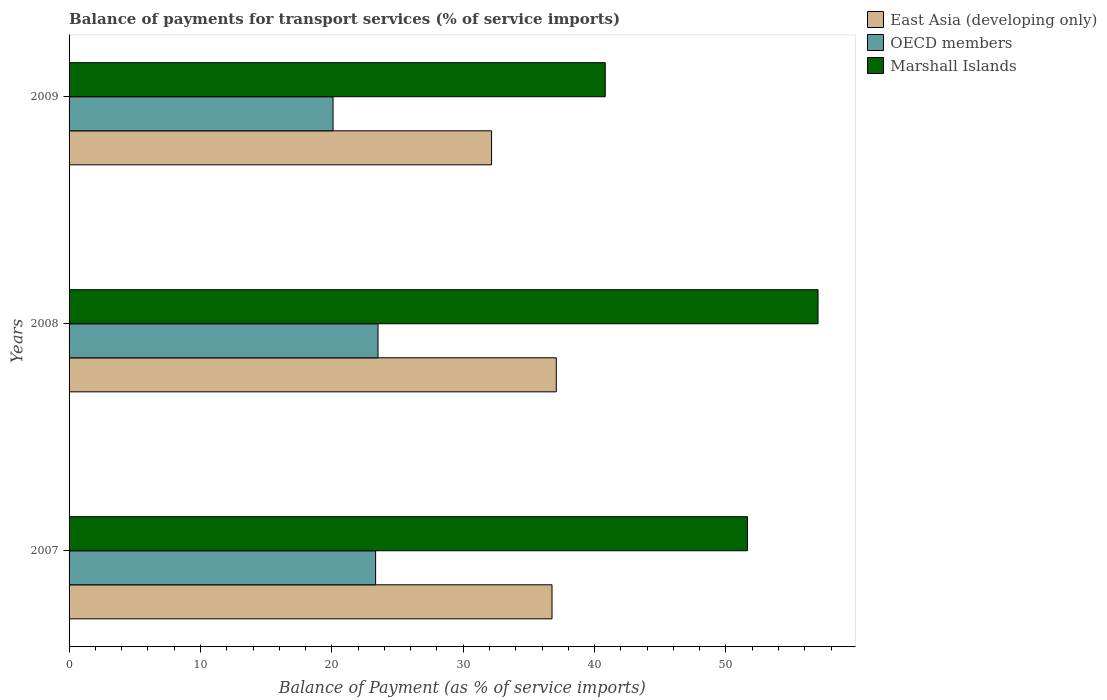How many groups of bars are there?
Offer a terse response. 3. Are the number of bars per tick equal to the number of legend labels?
Give a very brief answer. Yes. How many bars are there on the 3rd tick from the top?
Provide a succinct answer. 3. In how many cases, is the number of bars for a given year not equal to the number of legend labels?
Keep it short and to the point. 0. What is the balance of payments for transport services in Marshall Islands in 2008?
Ensure brevity in your answer.  57.01. Across all years, what is the maximum balance of payments for transport services in Marshall Islands?
Provide a short and direct response. 57.01. Across all years, what is the minimum balance of payments for transport services in Marshall Islands?
Provide a short and direct response. 40.81. What is the total balance of payments for transport services in OECD members in the graph?
Give a very brief answer. 66.94. What is the difference between the balance of payments for transport services in Marshall Islands in 2007 and that in 2009?
Offer a very short reply. 10.83. What is the difference between the balance of payments for transport services in East Asia (developing only) in 2009 and the balance of payments for transport services in OECD members in 2007?
Offer a very short reply. 8.83. What is the average balance of payments for transport services in East Asia (developing only) per year?
Your answer should be compact. 35.34. In the year 2008, what is the difference between the balance of payments for transport services in OECD members and balance of payments for transport services in Marshall Islands?
Your answer should be very brief. -33.49. What is the ratio of the balance of payments for transport services in Marshall Islands in 2007 to that in 2008?
Your answer should be very brief. 0.91. What is the difference between the highest and the second highest balance of payments for transport services in OECD members?
Ensure brevity in your answer.  0.18. What is the difference between the highest and the lowest balance of payments for transport services in Marshall Islands?
Your response must be concise. 16.2. What does the 1st bar from the top in 2008 represents?
Your answer should be compact. Marshall Islands. What does the 3rd bar from the bottom in 2009 represents?
Your answer should be very brief. Marshall Islands. Is it the case that in every year, the sum of the balance of payments for transport services in OECD members and balance of payments for transport services in Marshall Islands is greater than the balance of payments for transport services in East Asia (developing only)?
Offer a very short reply. Yes. What is the difference between two consecutive major ticks on the X-axis?
Provide a succinct answer. 10. Does the graph contain any zero values?
Your answer should be very brief. No. Does the graph contain grids?
Offer a terse response. No. How are the legend labels stacked?
Your answer should be compact. Vertical. What is the title of the graph?
Provide a succinct answer. Balance of payments for transport services (% of service imports). What is the label or title of the X-axis?
Provide a succinct answer. Balance of Payment (as % of service imports). What is the label or title of the Y-axis?
Offer a very short reply. Years. What is the Balance of Payment (as % of service imports) of East Asia (developing only) in 2007?
Ensure brevity in your answer.  36.76. What is the Balance of Payment (as % of service imports) in OECD members in 2007?
Ensure brevity in your answer.  23.33. What is the Balance of Payment (as % of service imports) of Marshall Islands in 2007?
Make the answer very short. 51.64. What is the Balance of Payment (as % of service imports) in East Asia (developing only) in 2008?
Make the answer very short. 37.09. What is the Balance of Payment (as % of service imports) of OECD members in 2008?
Your answer should be very brief. 23.52. What is the Balance of Payment (as % of service imports) in Marshall Islands in 2008?
Your answer should be very brief. 57.01. What is the Balance of Payment (as % of service imports) of East Asia (developing only) in 2009?
Your answer should be very brief. 32.16. What is the Balance of Payment (as % of service imports) of OECD members in 2009?
Provide a succinct answer. 20.09. What is the Balance of Payment (as % of service imports) in Marshall Islands in 2009?
Your response must be concise. 40.81. Across all years, what is the maximum Balance of Payment (as % of service imports) in East Asia (developing only)?
Ensure brevity in your answer.  37.09. Across all years, what is the maximum Balance of Payment (as % of service imports) of OECD members?
Provide a succinct answer. 23.52. Across all years, what is the maximum Balance of Payment (as % of service imports) in Marshall Islands?
Give a very brief answer. 57.01. Across all years, what is the minimum Balance of Payment (as % of service imports) of East Asia (developing only)?
Give a very brief answer. 32.16. Across all years, what is the minimum Balance of Payment (as % of service imports) of OECD members?
Ensure brevity in your answer.  20.09. Across all years, what is the minimum Balance of Payment (as % of service imports) in Marshall Islands?
Provide a succinct answer. 40.81. What is the total Balance of Payment (as % of service imports) in East Asia (developing only) in the graph?
Your answer should be compact. 106.01. What is the total Balance of Payment (as % of service imports) in OECD members in the graph?
Keep it short and to the point. 66.94. What is the total Balance of Payment (as % of service imports) of Marshall Islands in the graph?
Your answer should be compact. 149.46. What is the difference between the Balance of Payment (as % of service imports) in East Asia (developing only) in 2007 and that in 2008?
Your answer should be compact. -0.32. What is the difference between the Balance of Payment (as % of service imports) in OECD members in 2007 and that in 2008?
Your answer should be compact. -0.18. What is the difference between the Balance of Payment (as % of service imports) in Marshall Islands in 2007 and that in 2008?
Provide a short and direct response. -5.37. What is the difference between the Balance of Payment (as % of service imports) in East Asia (developing only) in 2007 and that in 2009?
Your answer should be compact. 4.6. What is the difference between the Balance of Payment (as % of service imports) of OECD members in 2007 and that in 2009?
Offer a very short reply. 3.24. What is the difference between the Balance of Payment (as % of service imports) in Marshall Islands in 2007 and that in 2009?
Ensure brevity in your answer.  10.83. What is the difference between the Balance of Payment (as % of service imports) in East Asia (developing only) in 2008 and that in 2009?
Ensure brevity in your answer.  4.93. What is the difference between the Balance of Payment (as % of service imports) in OECD members in 2008 and that in 2009?
Keep it short and to the point. 3.42. What is the difference between the Balance of Payment (as % of service imports) in Marshall Islands in 2008 and that in 2009?
Provide a succinct answer. 16.2. What is the difference between the Balance of Payment (as % of service imports) of East Asia (developing only) in 2007 and the Balance of Payment (as % of service imports) of OECD members in 2008?
Make the answer very short. 13.24. What is the difference between the Balance of Payment (as % of service imports) in East Asia (developing only) in 2007 and the Balance of Payment (as % of service imports) in Marshall Islands in 2008?
Provide a short and direct response. -20.25. What is the difference between the Balance of Payment (as % of service imports) in OECD members in 2007 and the Balance of Payment (as % of service imports) in Marshall Islands in 2008?
Make the answer very short. -33.68. What is the difference between the Balance of Payment (as % of service imports) in East Asia (developing only) in 2007 and the Balance of Payment (as % of service imports) in OECD members in 2009?
Ensure brevity in your answer.  16.67. What is the difference between the Balance of Payment (as % of service imports) in East Asia (developing only) in 2007 and the Balance of Payment (as % of service imports) in Marshall Islands in 2009?
Your answer should be very brief. -4.05. What is the difference between the Balance of Payment (as % of service imports) of OECD members in 2007 and the Balance of Payment (as % of service imports) of Marshall Islands in 2009?
Make the answer very short. -17.48. What is the difference between the Balance of Payment (as % of service imports) of East Asia (developing only) in 2008 and the Balance of Payment (as % of service imports) of OECD members in 2009?
Provide a short and direct response. 16.99. What is the difference between the Balance of Payment (as % of service imports) in East Asia (developing only) in 2008 and the Balance of Payment (as % of service imports) in Marshall Islands in 2009?
Provide a short and direct response. -3.73. What is the difference between the Balance of Payment (as % of service imports) in OECD members in 2008 and the Balance of Payment (as % of service imports) in Marshall Islands in 2009?
Offer a very short reply. -17.3. What is the average Balance of Payment (as % of service imports) of East Asia (developing only) per year?
Offer a very short reply. 35.34. What is the average Balance of Payment (as % of service imports) of OECD members per year?
Your response must be concise. 22.31. What is the average Balance of Payment (as % of service imports) of Marshall Islands per year?
Offer a terse response. 49.82. In the year 2007, what is the difference between the Balance of Payment (as % of service imports) in East Asia (developing only) and Balance of Payment (as % of service imports) in OECD members?
Provide a short and direct response. 13.43. In the year 2007, what is the difference between the Balance of Payment (as % of service imports) in East Asia (developing only) and Balance of Payment (as % of service imports) in Marshall Islands?
Ensure brevity in your answer.  -14.88. In the year 2007, what is the difference between the Balance of Payment (as % of service imports) in OECD members and Balance of Payment (as % of service imports) in Marshall Islands?
Your response must be concise. -28.31. In the year 2008, what is the difference between the Balance of Payment (as % of service imports) in East Asia (developing only) and Balance of Payment (as % of service imports) in OECD members?
Offer a terse response. 13.57. In the year 2008, what is the difference between the Balance of Payment (as % of service imports) of East Asia (developing only) and Balance of Payment (as % of service imports) of Marshall Islands?
Offer a terse response. -19.92. In the year 2008, what is the difference between the Balance of Payment (as % of service imports) of OECD members and Balance of Payment (as % of service imports) of Marshall Islands?
Your response must be concise. -33.49. In the year 2009, what is the difference between the Balance of Payment (as % of service imports) of East Asia (developing only) and Balance of Payment (as % of service imports) of OECD members?
Offer a terse response. 12.07. In the year 2009, what is the difference between the Balance of Payment (as % of service imports) in East Asia (developing only) and Balance of Payment (as % of service imports) in Marshall Islands?
Your answer should be compact. -8.65. In the year 2009, what is the difference between the Balance of Payment (as % of service imports) in OECD members and Balance of Payment (as % of service imports) in Marshall Islands?
Your answer should be compact. -20.72. What is the ratio of the Balance of Payment (as % of service imports) of East Asia (developing only) in 2007 to that in 2008?
Offer a very short reply. 0.99. What is the ratio of the Balance of Payment (as % of service imports) of Marshall Islands in 2007 to that in 2008?
Offer a terse response. 0.91. What is the ratio of the Balance of Payment (as % of service imports) in East Asia (developing only) in 2007 to that in 2009?
Keep it short and to the point. 1.14. What is the ratio of the Balance of Payment (as % of service imports) in OECD members in 2007 to that in 2009?
Provide a short and direct response. 1.16. What is the ratio of the Balance of Payment (as % of service imports) in Marshall Islands in 2007 to that in 2009?
Provide a short and direct response. 1.27. What is the ratio of the Balance of Payment (as % of service imports) in East Asia (developing only) in 2008 to that in 2009?
Offer a terse response. 1.15. What is the ratio of the Balance of Payment (as % of service imports) in OECD members in 2008 to that in 2009?
Make the answer very short. 1.17. What is the ratio of the Balance of Payment (as % of service imports) of Marshall Islands in 2008 to that in 2009?
Give a very brief answer. 1.4. What is the difference between the highest and the second highest Balance of Payment (as % of service imports) of East Asia (developing only)?
Provide a succinct answer. 0.32. What is the difference between the highest and the second highest Balance of Payment (as % of service imports) in OECD members?
Provide a short and direct response. 0.18. What is the difference between the highest and the second highest Balance of Payment (as % of service imports) in Marshall Islands?
Ensure brevity in your answer.  5.37. What is the difference between the highest and the lowest Balance of Payment (as % of service imports) in East Asia (developing only)?
Give a very brief answer. 4.93. What is the difference between the highest and the lowest Balance of Payment (as % of service imports) of OECD members?
Provide a succinct answer. 3.42. What is the difference between the highest and the lowest Balance of Payment (as % of service imports) in Marshall Islands?
Offer a terse response. 16.2. 